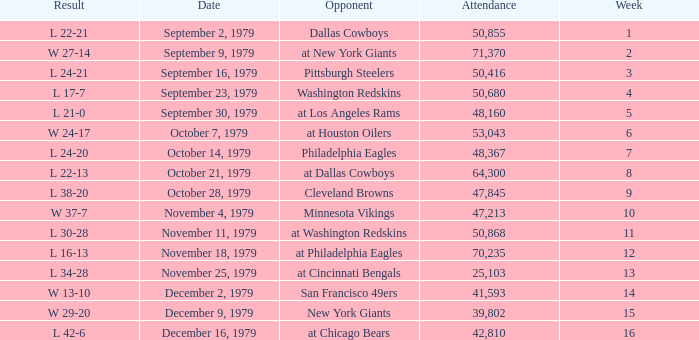What is the highest week when attendance is greater than 64,300 with a result of w 27-14? 2.0. 